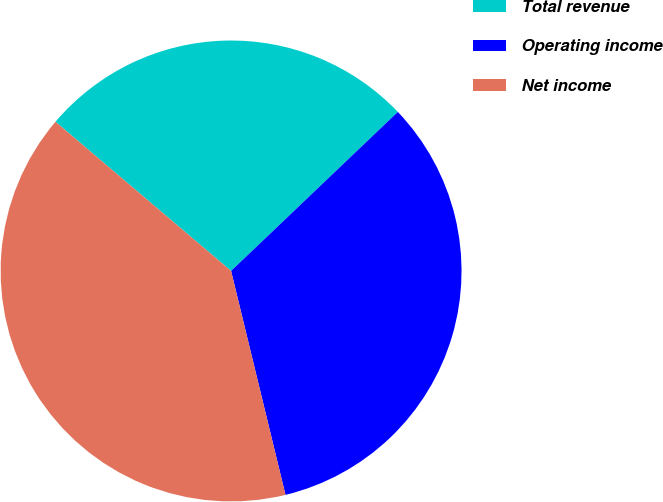Convert chart to OTSL. <chart><loc_0><loc_0><loc_500><loc_500><pie_chart><fcel>Total revenue<fcel>Operating income<fcel>Net income<nl><fcel>26.67%<fcel>33.33%<fcel>40.0%<nl></chart> 